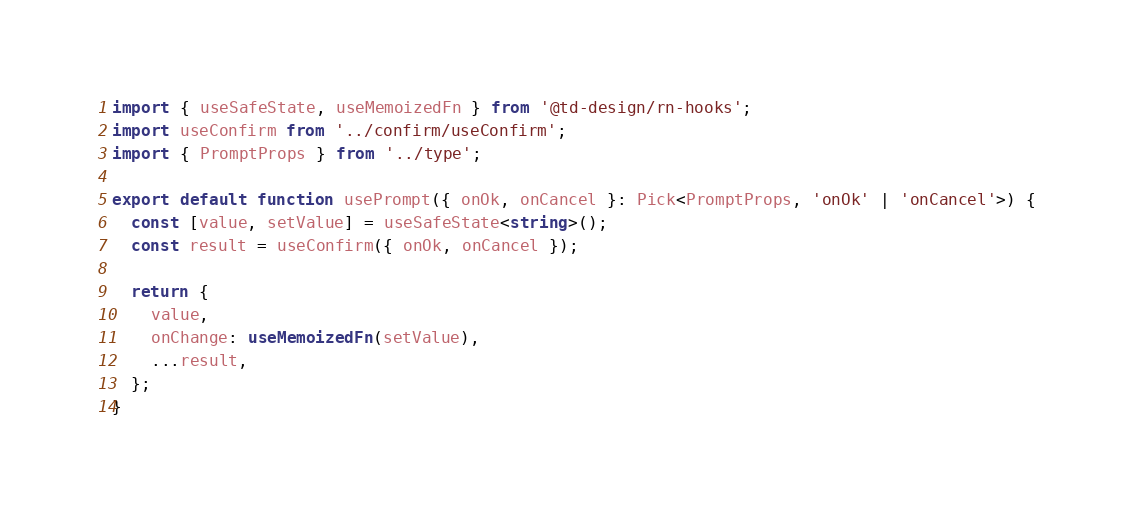<code> <loc_0><loc_0><loc_500><loc_500><_TypeScript_>import { useSafeState, useMemoizedFn } from '@td-design/rn-hooks';
import useConfirm from '../confirm/useConfirm';
import { PromptProps } from '../type';

export default function usePrompt({ onOk, onCancel }: Pick<PromptProps, 'onOk' | 'onCancel'>) {
  const [value, setValue] = useSafeState<string>();
  const result = useConfirm({ onOk, onCancel });

  return {
    value,
    onChange: useMemoizedFn(setValue),
    ...result,
  };
}
</code> 